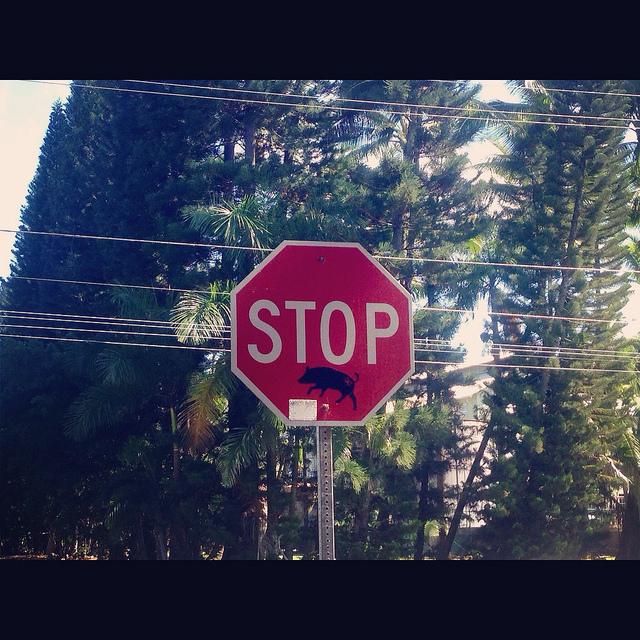What is likely to the left of the stop sign?
Answer briefly. Street. What picture is on the stop sign?
Write a very short answer. Pig. What does the sign say?
Be succinct. Stop. How many power lines are there?
Concise answer only. 9. 